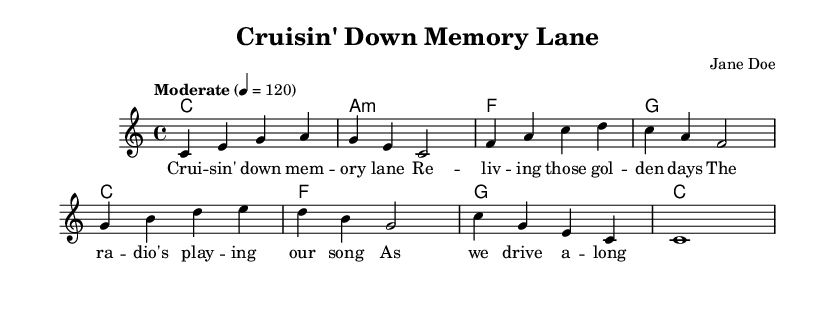What is the key signature of this music? The key signature is indicated in the global section as C major. C major has no sharps or flats. Hence, it is the key signature for this piece.
Answer: C major What is the time signature of this music? The time signature is noted in the global section and is defined as 4/4, meaning there are four beats in each measure, and the quarter note gets one beat.
Answer: 4/4 What is the tempo marking of this piece? The tempo is given in the global section as "Moderate" with a specific beat of 120. This indicates that the piece should be played at a moderate speed.
Answer: Moderate How many measures are in the melody? The melody consists of eight measures, each of which is separated by a vertical line. By counting the distinct sections where notes are grouped, you can determine the total number of measures.
Answer: 8 What is the first chord listed in the harmonies? The first chord in the harmonies section is indicated at the beginning of the chord mode as C major. This is the initial harmony in the piece.
Answer: C What is the lyrical theme of this song? The lyrics listed depict a nostalgic theme, focusing on reminiscing about the past while enjoying a road trip. This is suggested by phrases like “Cruisin' down memory lane” and “reliving those golden days.”
Answer: Nostalgia How many different chords are used in the harmonies? Upon reviewing the chord mode, there are four distinct chords present: C, A minor, F, and G. Counting these gives the total number of different chords used in this piece.
Answer: 4 